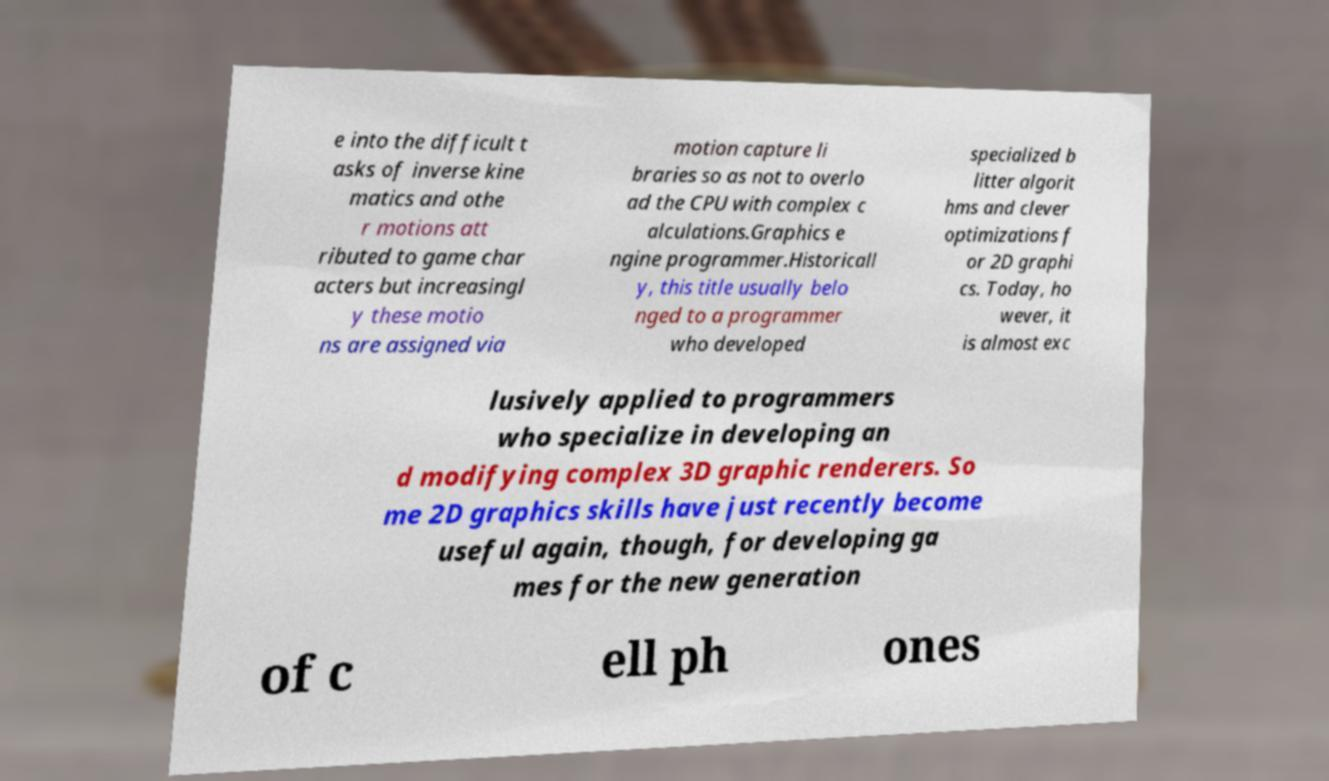What messages or text are displayed in this image? I need them in a readable, typed format. e into the difficult t asks of inverse kine matics and othe r motions att ributed to game char acters but increasingl y these motio ns are assigned via motion capture li braries so as not to overlo ad the CPU with complex c alculations.Graphics e ngine programmer.Historicall y, this title usually belo nged to a programmer who developed specialized b litter algorit hms and clever optimizations f or 2D graphi cs. Today, ho wever, it is almost exc lusively applied to programmers who specialize in developing an d modifying complex 3D graphic renderers. So me 2D graphics skills have just recently become useful again, though, for developing ga mes for the new generation of c ell ph ones 